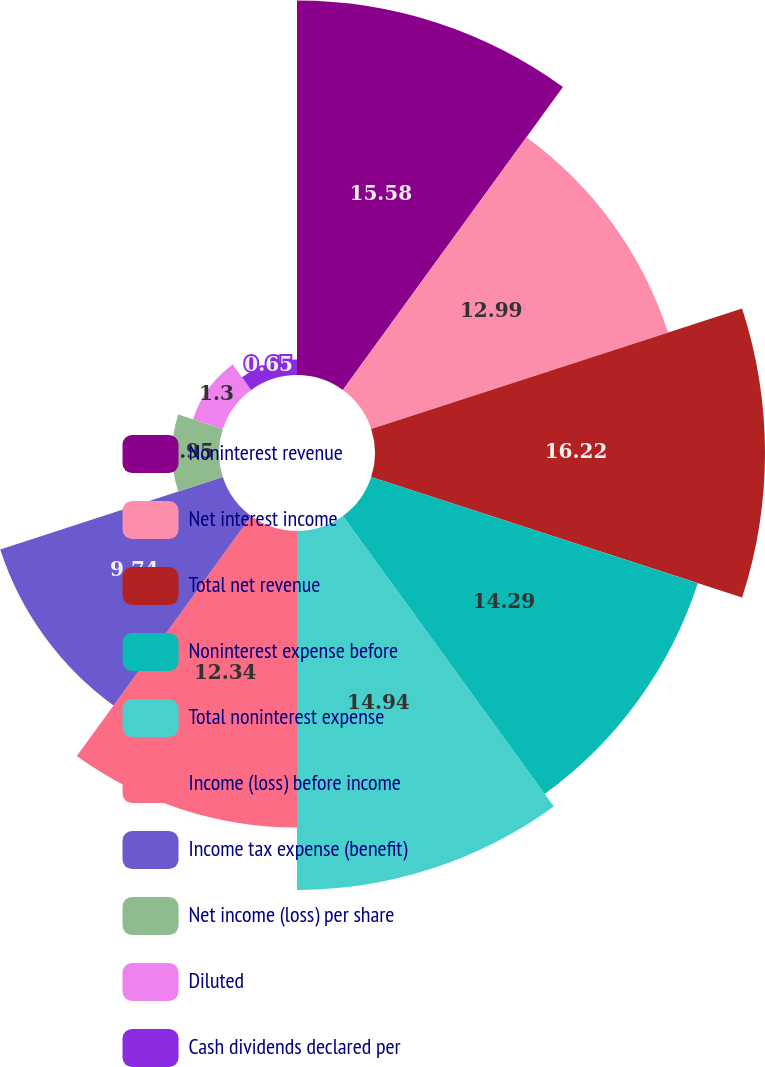Convert chart. <chart><loc_0><loc_0><loc_500><loc_500><pie_chart><fcel>Noninterest revenue<fcel>Net interest income<fcel>Total net revenue<fcel>Noninterest expense before<fcel>Total noninterest expense<fcel>Income (loss) before income<fcel>Income tax expense (benefit)<fcel>Net income (loss) per share<fcel>Diluted<fcel>Cash dividends declared per<nl><fcel>15.58%<fcel>12.99%<fcel>16.23%<fcel>14.29%<fcel>14.94%<fcel>12.34%<fcel>9.74%<fcel>1.95%<fcel>1.3%<fcel>0.65%<nl></chart> 